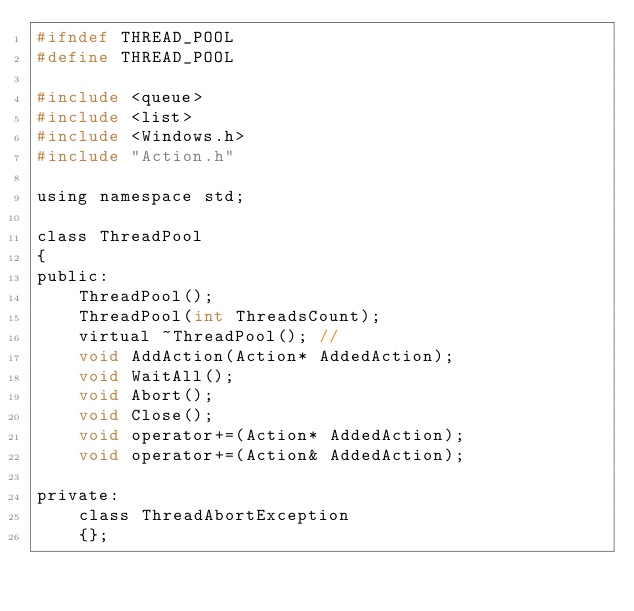<code> <loc_0><loc_0><loc_500><loc_500><_C_>#ifndef THREAD_POOL
#define THREAD_POOL

#include <queue>
#include <list>
#include <Windows.h>
#include "Action.h"

using namespace std;

class ThreadPool
{
public:
	ThreadPool();
	ThreadPool(int ThreadsCount);
	virtual ~ThreadPool(); //
	void AddAction(Action* AddedAction);
	void WaitAll();
	void Abort();
	void Close();
	void operator+=(Action* AddedAction);
	void operator+=(Action& AddedAction);

private:
	class ThreadAbortException
	{};
</code> 